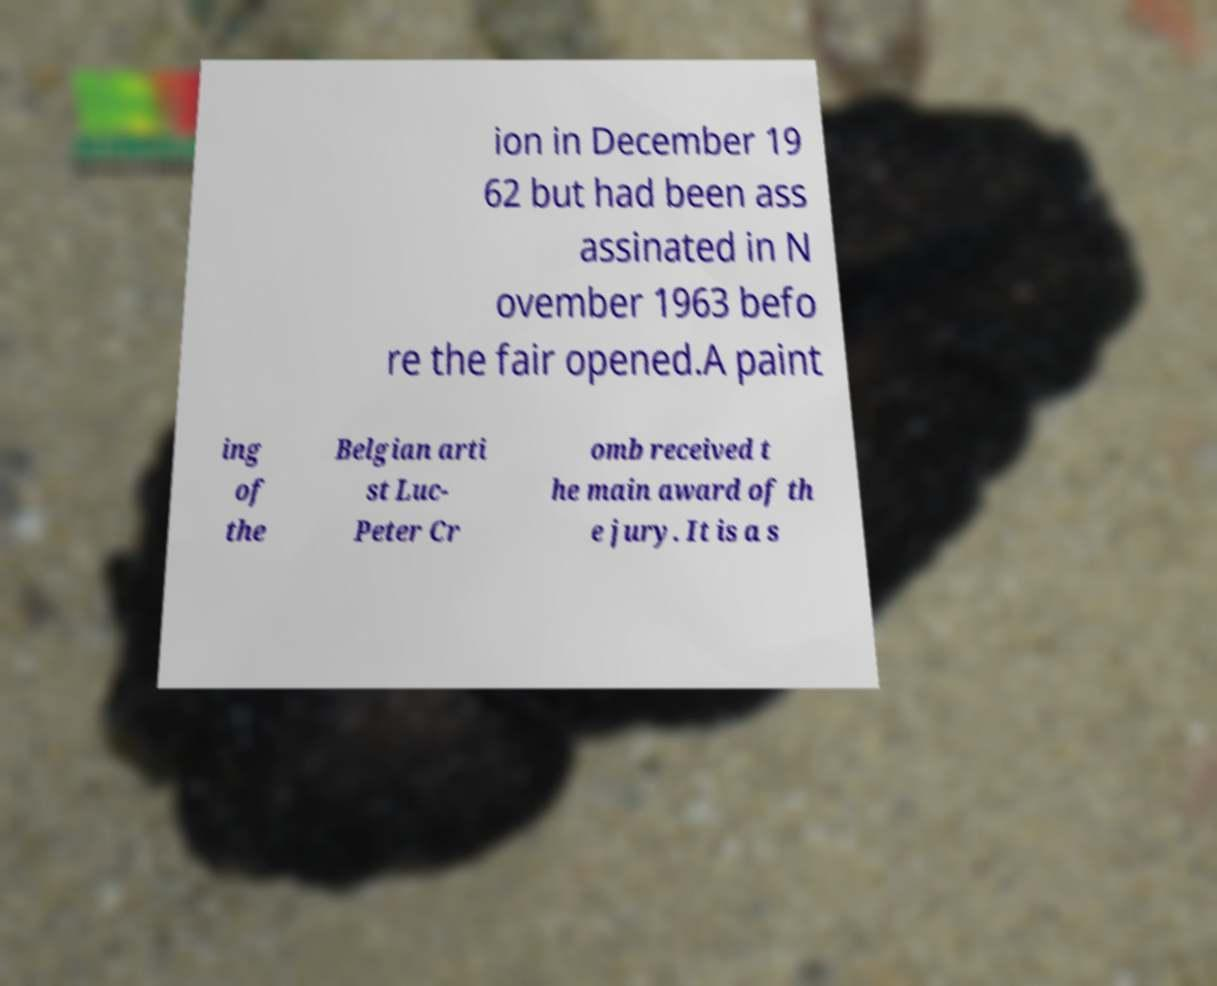For documentation purposes, I need the text within this image transcribed. Could you provide that? ion in December 19 62 but had been ass assinated in N ovember 1963 befo re the fair opened.A paint ing of the Belgian arti st Luc- Peter Cr omb received t he main award of th e jury. It is a s 